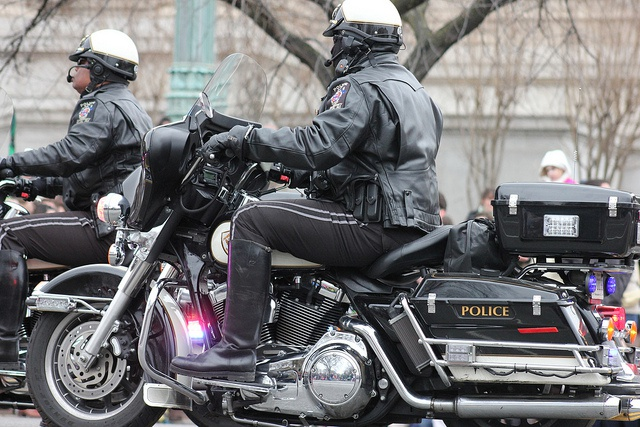Describe the objects in this image and their specific colors. I can see motorcycle in darkgray, black, gray, and lightgray tones, people in darkgray, black, gray, and lightgray tones, people in darkgray, black, gray, and white tones, motorcycle in darkgray, black, and gray tones, and people in darkgray, white, pink, and violet tones in this image. 